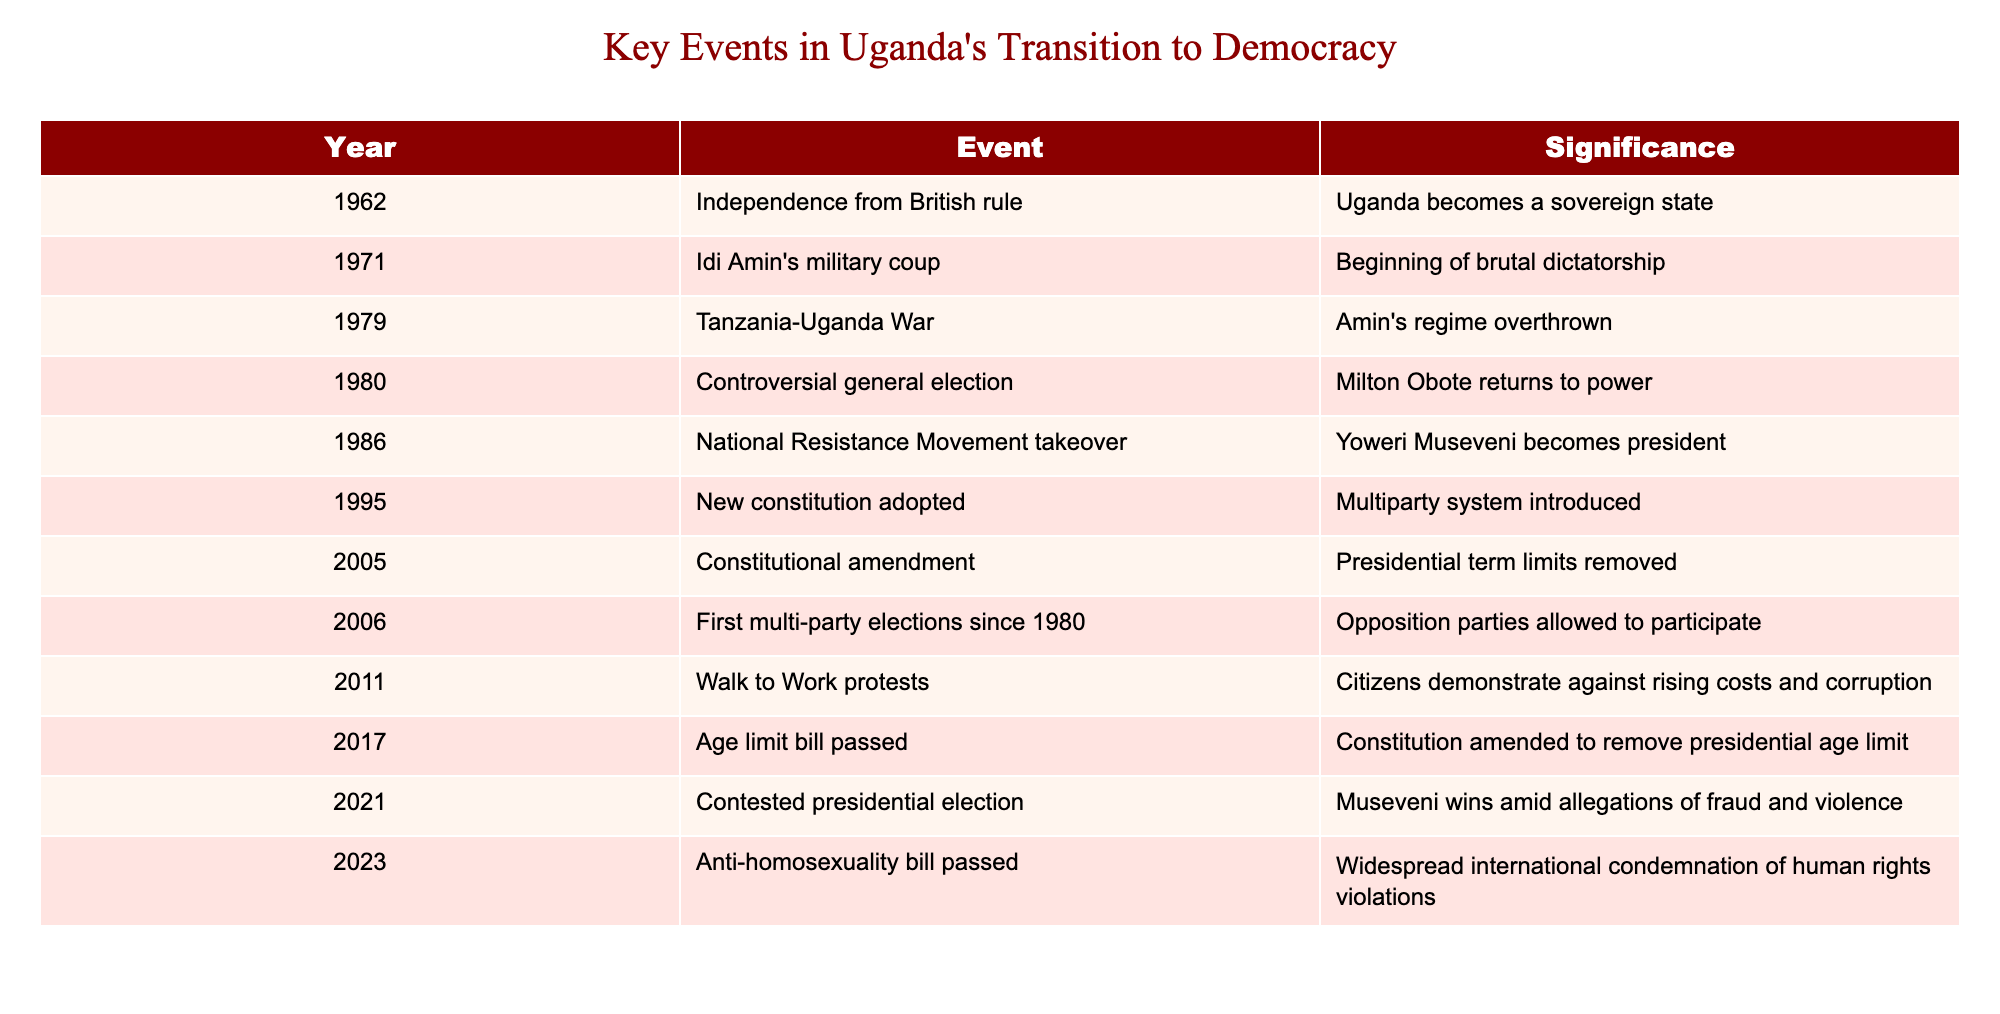What year did Uganda gain independence from British rule? The table indicates that Uganda gained independence in 1962. This is directly mentioned in the 'Year' column corresponding to the event 'Independence from British rule.'
Answer: 1962 What significant event occurred in 1986? According to the table, the year 1986 marks the National Resistance Movement takeover, where Yoweri Museveni becomes president. This information is explicitly stated in the 'Event' column for the year 1986.
Answer: National Resistance Movement takeover Was there a constitutional amendment in 2005? Yes, the table clearly shows that there was a constitutional amendment in 2005, specifically removing presidential term limits. This is a yes/no question based on the provided data.
Answer: Yes How many significant events occurred before 1990? The table lists significant events from 1962 to 1986, with a total of five events before 1990 (1962, 1971, 1979, 1980, and 1986). Counting these events gives us the answer.
Answer: 5 What is the significance of the events from 2011 and 2023? The event from 2011 involves the Walk to Work protests against rising costs and corruption, while the 2023 event concerns the Anti-homosexuality bill passed, which faced international condemnation for human rights violations. This understanding is derived from reading the significance of each event listed in the table for those years.
Answer: Protests in 2011; Human rights violations in 2023 What event had a direct impact on the presidential age limit? The table shows that the age limit bill was passed in 2017, leading to a constitutional amendment to remove the presidential age limit. This directly indicates it was a significant event affecting the age limit for presidency in Uganda.
Answer: Age limit bill passed in 2017 Which event indicates the introduction of a multiparty system? The table indicates that the adoption of a new constitution in 1995 introduced a multiparty system. We can find this information by looking for the significance of the 1995 event in the 'Significance' column.
Answer: New constitution adopted What is the time gap between Amin’s military coup and Museveni becoming president? Amin's military coup happened in 1971, and Museveni became president in 1986. The time difference is calculated by subtracting the years, which gives us 1986 - 1971 = 15 years. Thus, it takes 15 years between these two significant events.
Answer: 15 years 